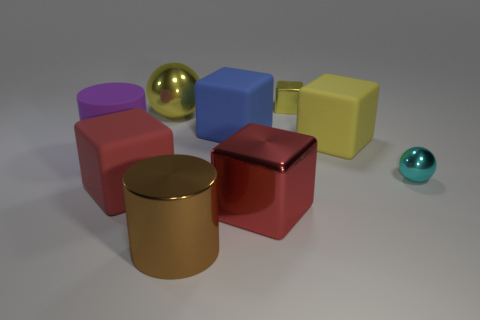What number of blue rubber things are to the right of the brown cylinder? There is one blue rubber ball to the right of the brown cylinder. 